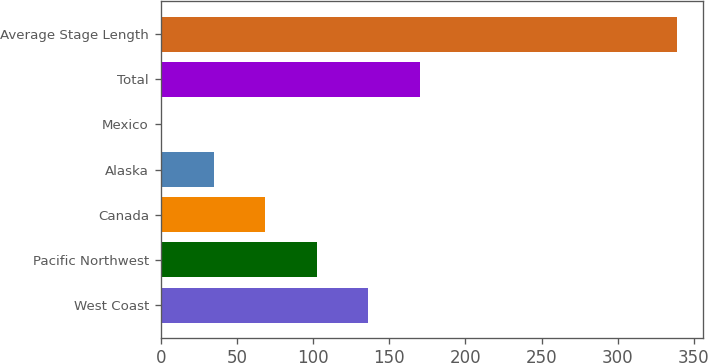Convert chart to OTSL. <chart><loc_0><loc_0><loc_500><loc_500><bar_chart><fcel>West Coast<fcel>Pacific Northwest<fcel>Canada<fcel>Alaska<fcel>Mexico<fcel>Total<fcel>Average Stage Length<nl><fcel>136.2<fcel>102.4<fcel>68.6<fcel>34.8<fcel>1<fcel>170<fcel>339<nl></chart> 